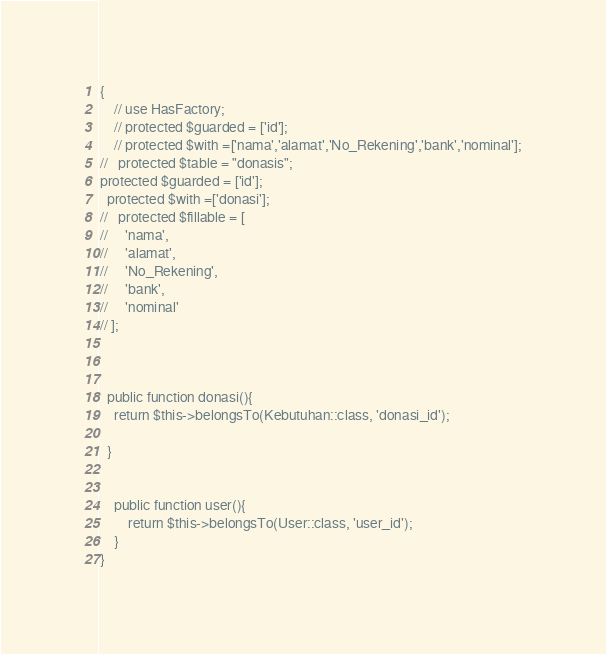<code> <loc_0><loc_0><loc_500><loc_500><_PHP_>{
    // use HasFactory;
    // protected $guarded = ['id'];
    // protected $with =['nama','alamat','No_Rekening','bank','nominal'];
//   protected $table = "donasis";
protected $guarded = ['id'];
  protected $with =['donasi'];
//   protected $fillable = [
//     'nama',
//     'alamat',
//     'No_Rekening',
//     'bank',
//     'nominal'
// ];



  public function donasi(){
    return $this->belongsTo(Kebutuhan::class, 'donasi_id');

  }


    public function user(){
        return $this->belongsTo(User::class, 'user_id');
    }
}
</code> 